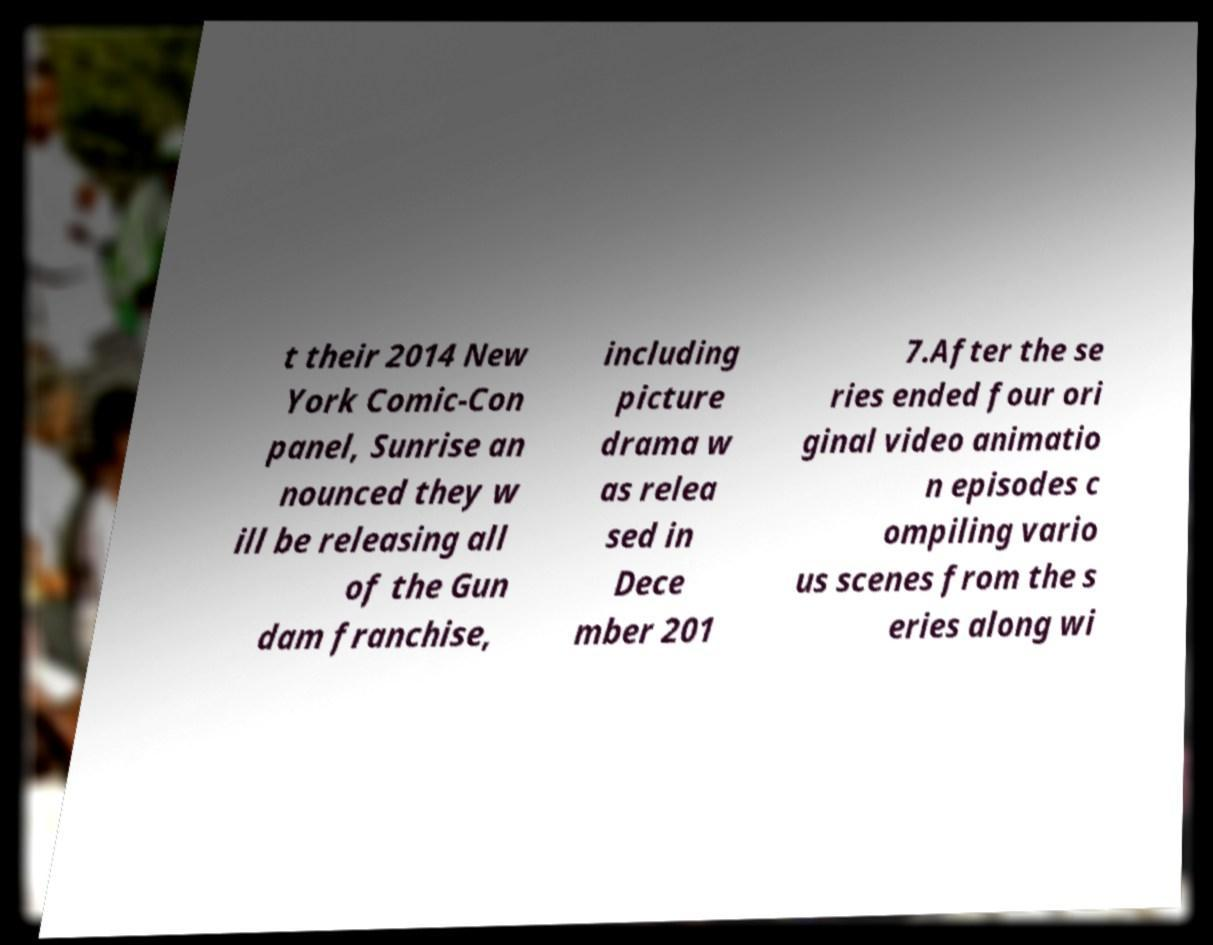For documentation purposes, I need the text within this image transcribed. Could you provide that? t their 2014 New York Comic-Con panel, Sunrise an nounced they w ill be releasing all of the Gun dam franchise, including picture drama w as relea sed in Dece mber 201 7.After the se ries ended four ori ginal video animatio n episodes c ompiling vario us scenes from the s eries along wi 